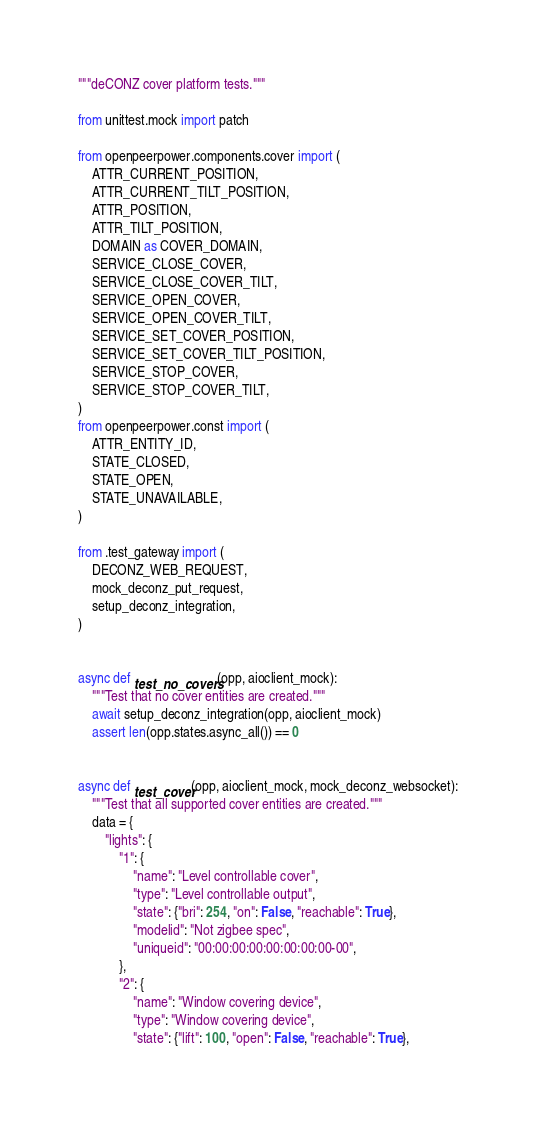Convert code to text. <code><loc_0><loc_0><loc_500><loc_500><_Python_>"""deCONZ cover platform tests."""

from unittest.mock import patch

from openpeerpower.components.cover import (
    ATTR_CURRENT_POSITION,
    ATTR_CURRENT_TILT_POSITION,
    ATTR_POSITION,
    ATTR_TILT_POSITION,
    DOMAIN as COVER_DOMAIN,
    SERVICE_CLOSE_COVER,
    SERVICE_CLOSE_COVER_TILT,
    SERVICE_OPEN_COVER,
    SERVICE_OPEN_COVER_TILT,
    SERVICE_SET_COVER_POSITION,
    SERVICE_SET_COVER_TILT_POSITION,
    SERVICE_STOP_COVER,
    SERVICE_STOP_COVER_TILT,
)
from openpeerpower.const import (
    ATTR_ENTITY_ID,
    STATE_CLOSED,
    STATE_OPEN,
    STATE_UNAVAILABLE,
)

from .test_gateway import (
    DECONZ_WEB_REQUEST,
    mock_deconz_put_request,
    setup_deconz_integration,
)


async def test_no_covers(opp, aioclient_mock):
    """Test that no cover entities are created."""
    await setup_deconz_integration(opp, aioclient_mock)
    assert len(opp.states.async_all()) == 0


async def test_cover(opp, aioclient_mock, mock_deconz_websocket):
    """Test that all supported cover entities are created."""
    data = {
        "lights": {
            "1": {
                "name": "Level controllable cover",
                "type": "Level controllable output",
                "state": {"bri": 254, "on": False, "reachable": True},
                "modelid": "Not zigbee spec",
                "uniqueid": "00:00:00:00:00:00:00:00-00",
            },
            "2": {
                "name": "Window covering device",
                "type": "Window covering device",
                "state": {"lift": 100, "open": False, "reachable": True},</code> 